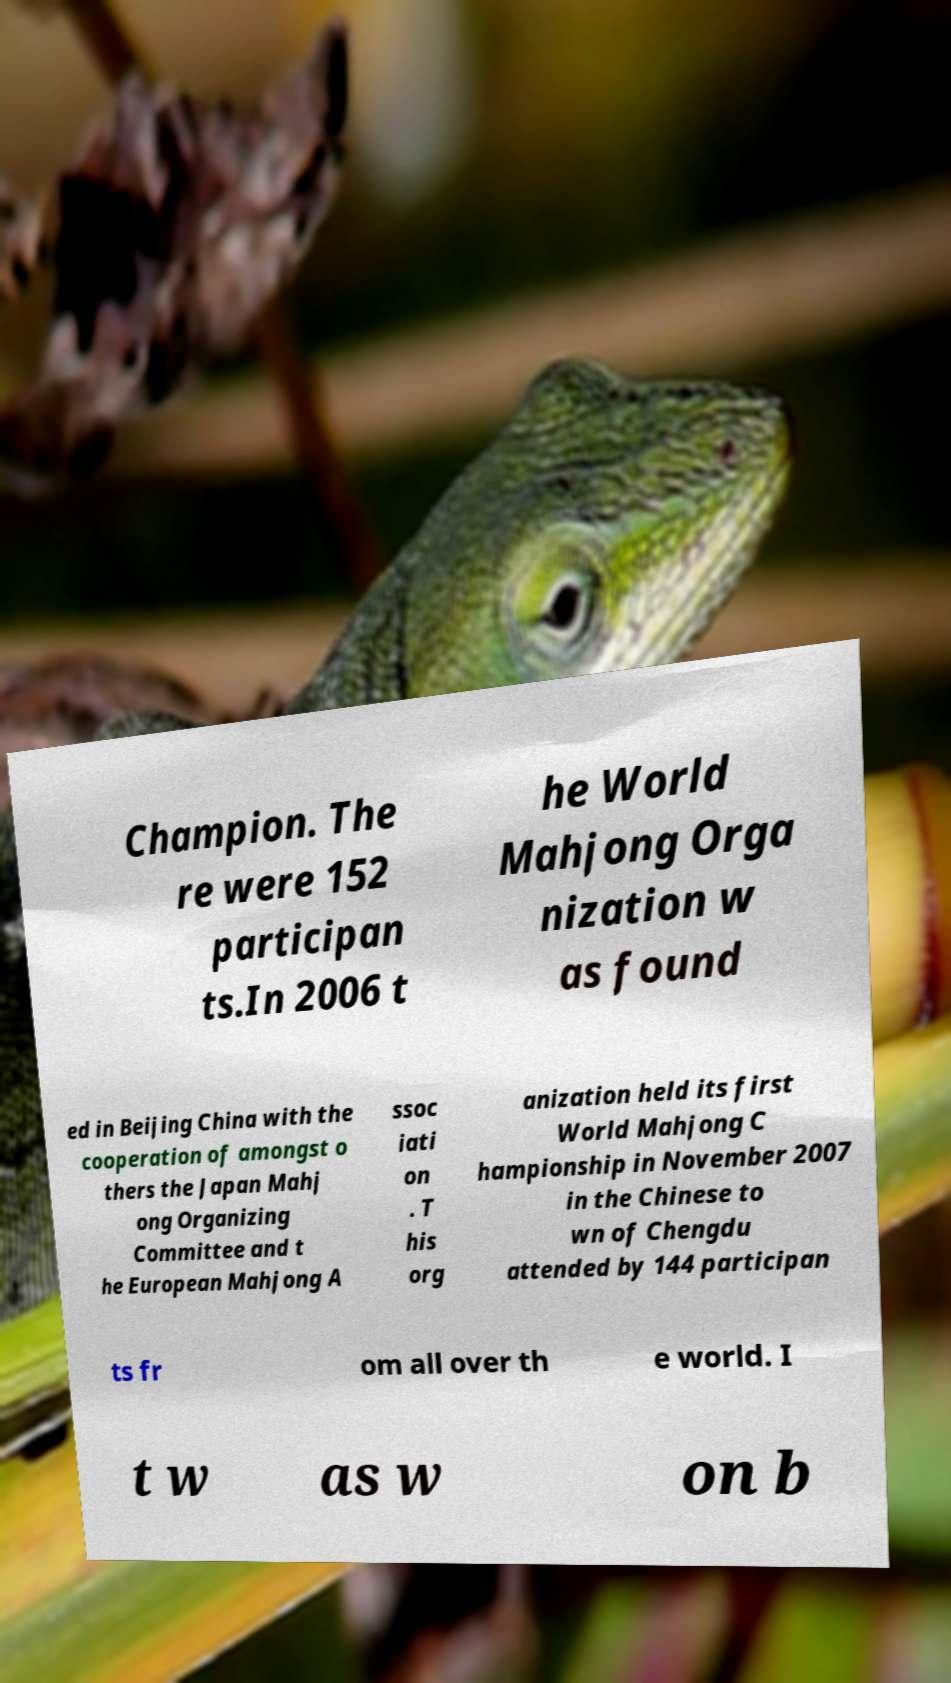Please identify and transcribe the text found in this image. Champion. The re were 152 participan ts.In 2006 t he World Mahjong Orga nization w as found ed in Beijing China with the cooperation of amongst o thers the Japan Mahj ong Organizing Committee and t he European Mahjong A ssoc iati on . T his org anization held its first World Mahjong C hampionship in November 2007 in the Chinese to wn of Chengdu attended by 144 participan ts fr om all over th e world. I t w as w on b 